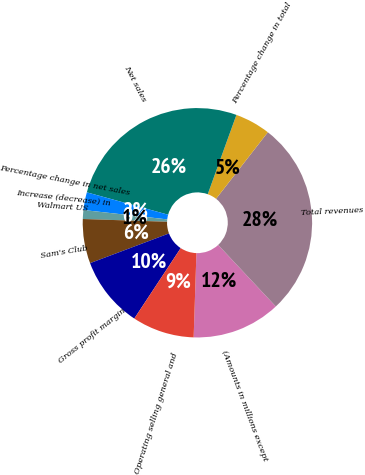Convert chart to OTSL. <chart><loc_0><loc_0><loc_500><loc_500><pie_chart><fcel>(Amounts in millions except<fcel>Total revenues<fcel>Percentage change in total<fcel>Net sales<fcel>Percentage change in net sales<fcel>Increase (decrease) in<fcel>Walmart US<fcel>Sam's Club<fcel>Gross profit margin<fcel>Operating selling general and<nl><fcel>12.5%<fcel>27.5%<fcel>5.0%<fcel>26.25%<fcel>2.5%<fcel>0.0%<fcel>1.25%<fcel>6.25%<fcel>10.0%<fcel>8.75%<nl></chart> 